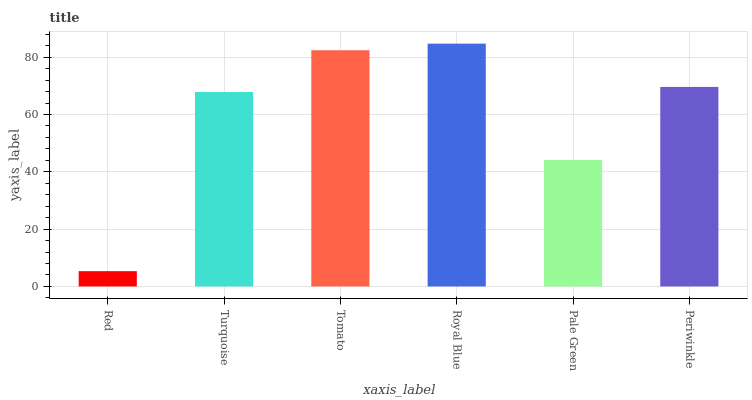Is Red the minimum?
Answer yes or no. Yes. Is Royal Blue the maximum?
Answer yes or no. Yes. Is Turquoise the minimum?
Answer yes or no. No. Is Turquoise the maximum?
Answer yes or no. No. Is Turquoise greater than Red?
Answer yes or no. Yes. Is Red less than Turquoise?
Answer yes or no. Yes. Is Red greater than Turquoise?
Answer yes or no. No. Is Turquoise less than Red?
Answer yes or no. No. Is Periwinkle the high median?
Answer yes or no. Yes. Is Turquoise the low median?
Answer yes or no. Yes. Is Turquoise the high median?
Answer yes or no. No. Is Periwinkle the low median?
Answer yes or no. No. 